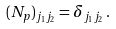<formula> <loc_0><loc_0><loc_500><loc_500>( N _ { p } ) _ { j _ { 1 } j _ { 2 } } = \delta _ { j _ { 1 } j _ { 2 } } \, .</formula> 